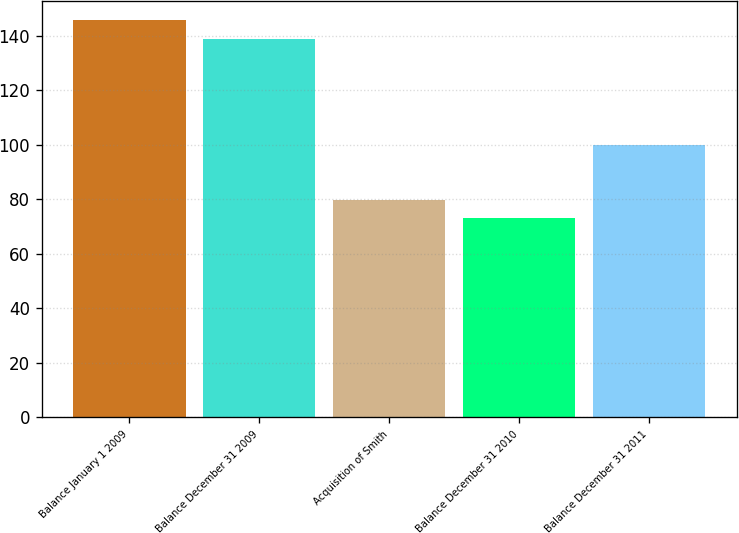Convert chart to OTSL. <chart><loc_0><loc_0><loc_500><loc_500><bar_chart><fcel>Balance January 1 2009<fcel>Balance December 31 2009<fcel>Acquisition of Smith<fcel>Balance December 31 2010<fcel>Balance December 31 2011<nl><fcel>145.7<fcel>139<fcel>79.7<fcel>73<fcel>100<nl></chart> 